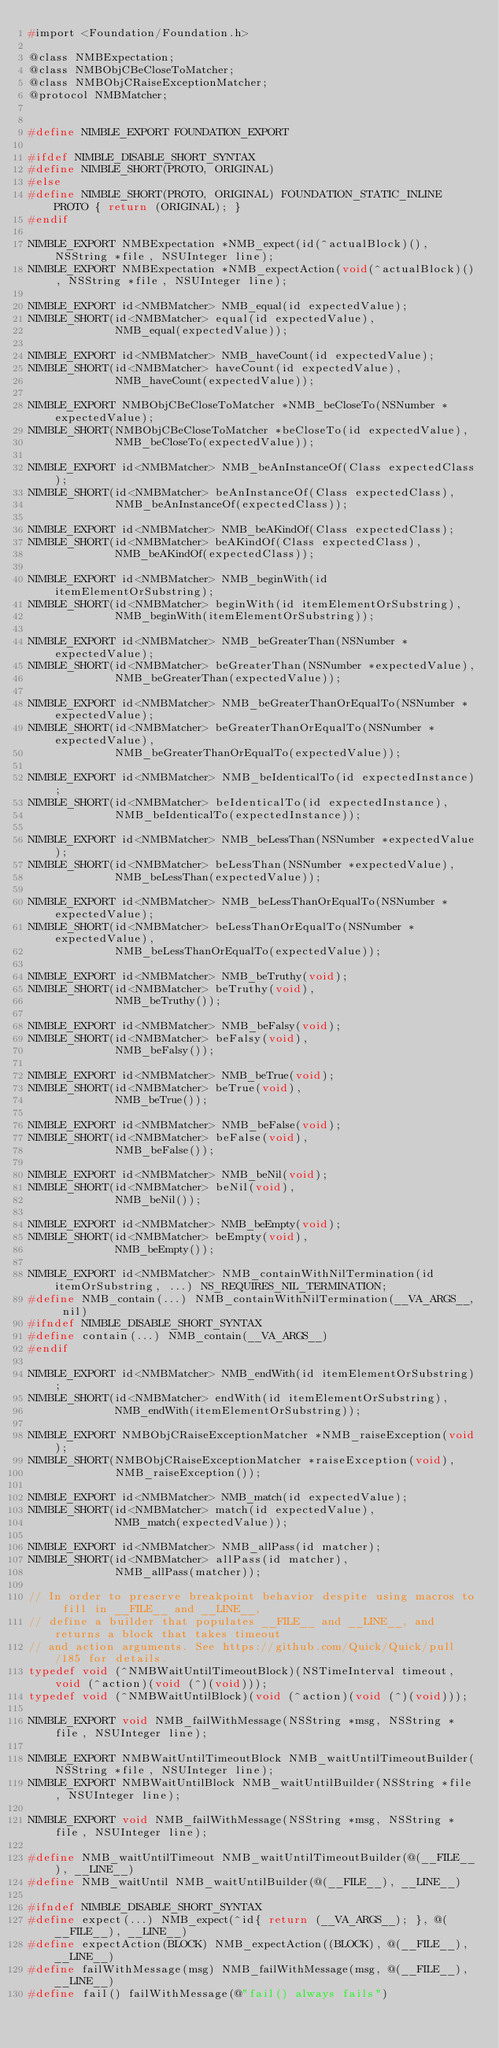Convert code to text. <code><loc_0><loc_0><loc_500><loc_500><_C_>#import <Foundation/Foundation.h>

@class NMBExpectation;
@class NMBObjCBeCloseToMatcher;
@class NMBObjCRaiseExceptionMatcher;
@protocol NMBMatcher;


#define NIMBLE_EXPORT FOUNDATION_EXPORT

#ifdef NIMBLE_DISABLE_SHORT_SYNTAX
#define NIMBLE_SHORT(PROTO, ORIGINAL)
#else
#define NIMBLE_SHORT(PROTO, ORIGINAL) FOUNDATION_STATIC_INLINE PROTO { return (ORIGINAL); }
#endif

NIMBLE_EXPORT NMBExpectation *NMB_expect(id(^actualBlock)(), NSString *file, NSUInteger line);
NIMBLE_EXPORT NMBExpectation *NMB_expectAction(void(^actualBlock)(), NSString *file, NSUInteger line);

NIMBLE_EXPORT id<NMBMatcher> NMB_equal(id expectedValue);
NIMBLE_SHORT(id<NMBMatcher> equal(id expectedValue),
             NMB_equal(expectedValue));

NIMBLE_EXPORT id<NMBMatcher> NMB_haveCount(id expectedValue);
NIMBLE_SHORT(id<NMBMatcher> haveCount(id expectedValue),
             NMB_haveCount(expectedValue));

NIMBLE_EXPORT NMBObjCBeCloseToMatcher *NMB_beCloseTo(NSNumber *expectedValue);
NIMBLE_SHORT(NMBObjCBeCloseToMatcher *beCloseTo(id expectedValue),
             NMB_beCloseTo(expectedValue));

NIMBLE_EXPORT id<NMBMatcher> NMB_beAnInstanceOf(Class expectedClass);
NIMBLE_SHORT(id<NMBMatcher> beAnInstanceOf(Class expectedClass),
             NMB_beAnInstanceOf(expectedClass));

NIMBLE_EXPORT id<NMBMatcher> NMB_beAKindOf(Class expectedClass);
NIMBLE_SHORT(id<NMBMatcher> beAKindOf(Class expectedClass),
             NMB_beAKindOf(expectedClass));

NIMBLE_EXPORT id<NMBMatcher> NMB_beginWith(id itemElementOrSubstring);
NIMBLE_SHORT(id<NMBMatcher> beginWith(id itemElementOrSubstring),
             NMB_beginWith(itemElementOrSubstring));

NIMBLE_EXPORT id<NMBMatcher> NMB_beGreaterThan(NSNumber *expectedValue);
NIMBLE_SHORT(id<NMBMatcher> beGreaterThan(NSNumber *expectedValue),
             NMB_beGreaterThan(expectedValue));

NIMBLE_EXPORT id<NMBMatcher> NMB_beGreaterThanOrEqualTo(NSNumber *expectedValue);
NIMBLE_SHORT(id<NMBMatcher> beGreaterThanOrEqualTo(NSNumber *expectedValue),
             NMB_beGreaterThanOrEqualTo(expectedValue));

NIMBLE_EXPORT id<NMBMatcher> NMB_beIdenticalTo(id expectedInstance);
NIMBLE_SHORT(id<NMBMatcher> beIdenticalTo(id expectedInstance),
             NMB_beIdenticalTo(expectedInstance));

NIMBLE_EXPORT id<NMBMatcher> NMB_beLessThan(NSNumber *expectedValue);
NIMBLE_SHORT(id<NMBMatcher> beLessThan(NSNumber *expectedValue),
             NMB_beLessThan(expectedValue));

NIMBLE_EXPORT id<NMBMatcher> NMB_beLessThanOrEqualTo(NSNumber *expectedValue);
NIMBLE_SHORT(id<NMBMatcher> beLessThanOrEqualTo(NSNumber *expectedValue),
             NMB_beLessThanOrEqualTo(expectedValue));

NIMBLE_EXPORT id<NMBMatcher> NMB_beTruthy(void);
NIMBLE_SHORT(id<NMBMatcher> beTruthy(void),
             NMB_beTruthy());

NIMBLE_EXPORT id<NMBMatcher> NMB_beFalsy(void);
NIMBLE_SHORT(id<NMBMatcher> beFalsy(void),
             NMB_beFalsy());

NIMBLE_EXPORT id<NMBMatcher> NMB_beTrue(void);
NIMBLE_SHORT(id<NMBMatcher> beTrue(void),
             NMB_beTrue());

NIMBLE_EXPORT id<NMBMatcher> NMB_beFalse(void);
NIMBLE_SHORT(id<NMBMatcher> beFalse(void),
             NMB_beFalse());

NIMBLE_EXPORT id<NMBMatcher> NMB_beNil(void);
NIMBLE_SHORT(id<NMBMatcher> beNil(void),
             NMB_beNil());

NIMBLE_EXPORT id<NMBMatcher> NMB_beEmpty(void);
NIMBLE_SHORT(id<NMBMatcher> beEmpty(void),
             NMB_beEmpty());

NIMBLE_EXPORT id<NMBMatcher> NMB_containWithNilTermination(id itemOrSubstring, ...) NS_REQUIRES_NIL_TERMINATION;
#define NMB_contain(...) NMB_containWithNilTermination(__VA_ARGS__, nil)
#ifndef NIMBLE_DISABLE_SHORT_SYNTAX
#define contain(...) NMB_contain(__VA_ARGS__)
#endif

NIMBLE_EXPORT id<NMBMatcher> NMB_endWith(id itemElementOrSubstring);
NIMBLE_SHORT(id<NMBMatcher> endWith(id itemElementOrSubstring),
             NMB_endWith(itemElementOrSubstring));

NIMBLE_EXPORT NMBObjCRaiseExceptionMatcher *NMB_raiseException(void);
NIMBLE_SHORT(NMBObjCRaiseExceptionMatcher *raiseException(void),
             NMB_raiseException());

NIMBLE_EXPORT id<NMBMatcher> NMB_match(id expectedValue);
NIMBLE_SHORT(id<NMBMatcher> match(id expectedValue),
             NMB_match(expectedValue));

NIMBLE_EXPORT id<NMBMatcher> NMB_allPass(id matcher);
NIMBLE_SHORT(id<NMBMatcher> allPass(id matcher),
             NMB_allPass(matcher));

// In order to preserve breakpoint behavior despite using macros to fill in __FILE__ and __LINE__,
// define a builder that populates __FILE__ and __LINE__, and returns a block that takes timeout
// and action arguments. See https://github.com/Quick/Quick/pull/185 for details.
typedef void (^NMBWaitUntilTimeoutBlock)(NSTimeInterval timeout, void (^action)(void (^)(void)));
typedef void (^NMBWaitUntilBlock)(void (^action)(void (^)(void)));

NIMBLE_EXPORT void NMB_failWithMessage(NSString *msg, NSString *file, NSUInteger line);

NIMBLE_EXPORT NMBWaitUntilTimeoutBlock NMB_waitUntilTimeoutBuilder(NSString *file, NSUInteger line);
NIMBLE_EXPORT NMBWaitUntilBlock NMB_waitUntilBuilder(NSString *file, NSUInteger line);

NIMBLE_EXPORT void NMB_failWithMessage(NSString *msg, NSString *file, NSUInteger line);

#define NMB_waitUntilTimeout NMB_waitUntilTimeoutBuilder(@(__FILE__), __LINE__)
#define NMB_waitUntil NMB_waitUntilBuilder(@(__FILE__), __LINE__)

#ifndef NIMBLE_DISABLE_SHORT_SYNTAX
#define expect(...) NMB_expect(^id{ return (__VA_ARGS__); }, @(__FILE__), __LINE__)
#define expectAction(BLOCK) NMB_expectAction((BLOCK), @(__FILE__), __LINE__)
#define failWithMessage(msg) NMB_failWithMessage(msg, @(__FILE__), __LINE__)
#define fail() failWithMessage(@"fail() always fails")

</code> 